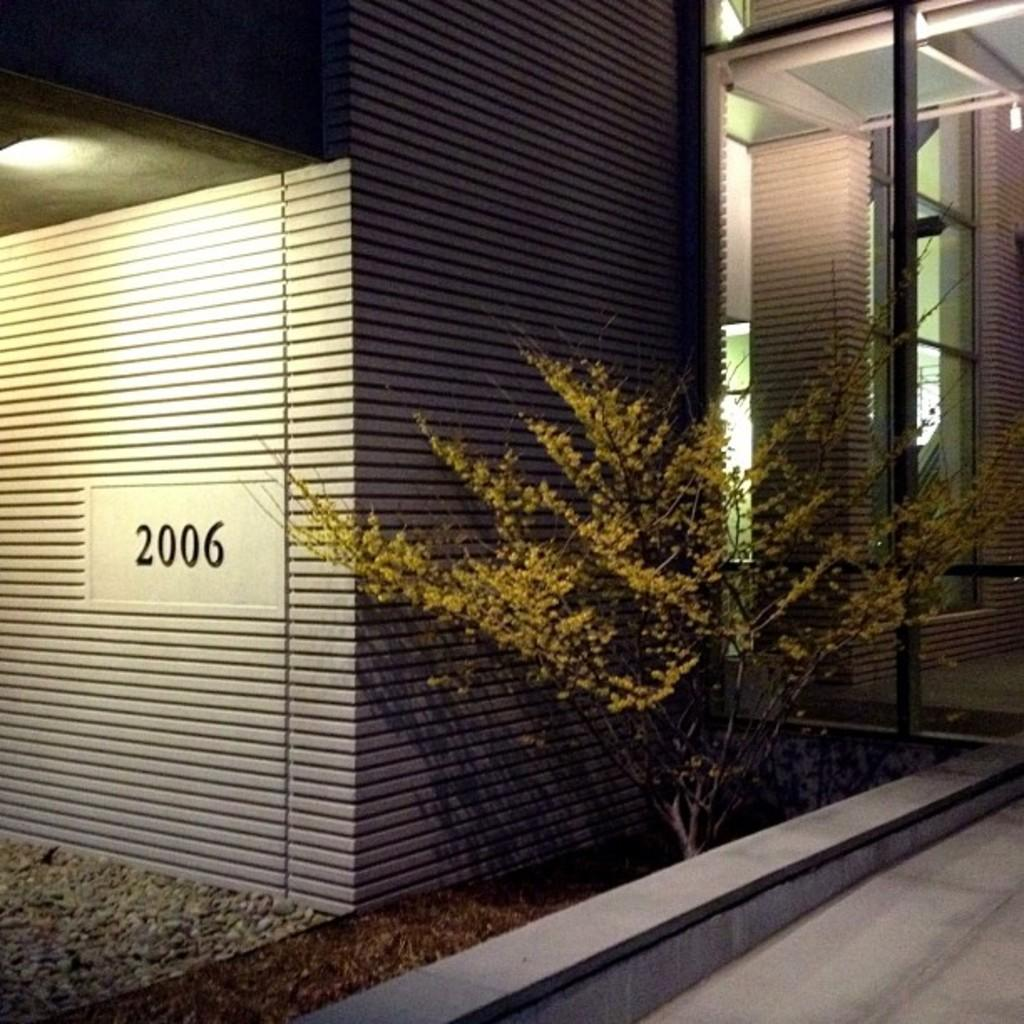What type of vegetation is on the right side of the image? There is a plant on the right side of the image. What is the material of the wall visible in the image? There is a glass wall in the image. What is the source of light on the left side of the image? There is a light on the left side of the image. What type of holiday is being celebrated in the image? There is no indication of a holiday being celebrated in the image. Can you see any poisonous substances in the image? There is no mention or indication of any poisonous substances in the image. Are there any snails visible on the plant in the image? There is no mention or indication of any snails on the plant in the image. 